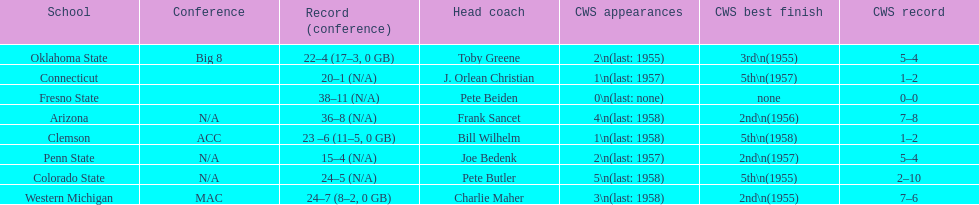How many cws appearances does clemson have? 1\n(last: 1958). How many cws appearances does western michigan have? 3\n(last: 1958). Which of these schools has more cws appearances? Western Michigan. 